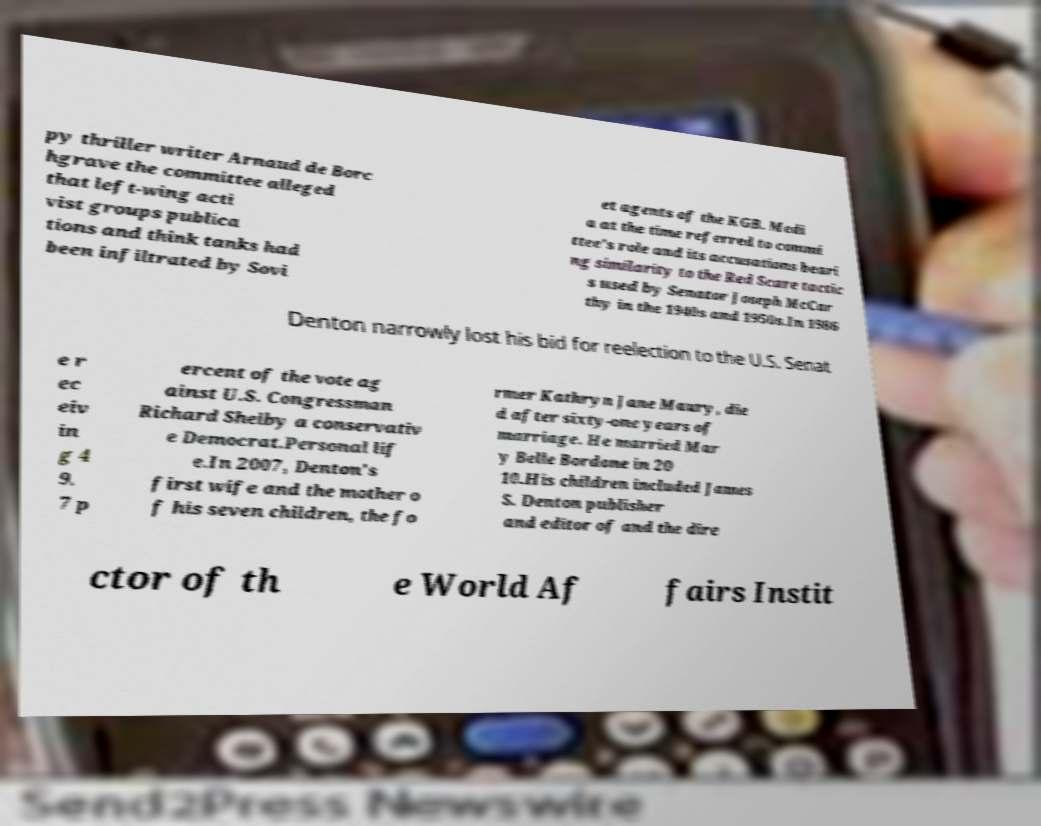Can you read and provide the text displayed in the image?This photo seems to have some interesting text. Can you extract and type it out for me? py thriller writer Arnaud de Borc hgrave the committee alleged that left-wing acti vist groups publica tions and think tanks had been infiltrated by Sovi et agents of the KGB. Medi a at the time referred to commi ttee's role and its accusations beari ng similarity to the Red Scare tactic s used by Senator Joseph McCar thy in the 1940s and 1950s.In 1986 Denton narrowly lost his bid for reelection to the U.S. Senat e r ec eiv in g 4 9. 7 p ercent of the vote ag ainst U.S. Congressman Richard Shelby a conservativ e Democrat.Personal lif e.In 2007, Denton's first wife and the mother o f his seven children, the fo rmer Kathryn Jane Maury, die d after sixty-one years of marriage. He married Mar y Belle Bordone in 20 10.His children included James S. Denton publisher and editor of and the dire ctor of th e World Af fairs Instit 